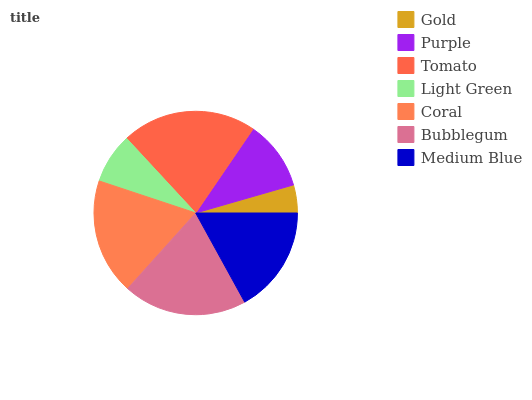Is Gold the minimum?
Answer yes or no. Yes. Is Tomato the maximum?
Answer yes or no. Yes. Is Purple the minimum?
Answer yes or no. No. Is Purple the maximum?
Answer yes or no. No. Is Purple greater than Gold?
Answer yes or no. Yes. Is Gold less than Purple?
Answer yes or no. Yes. Is Gold greater than Purple?
Answer yes or no. No. Is Purple less than Gold?
Answer yes or no. No. Is Medium Blue the high median?
Answer yes or no. Yes. Is Medium Blue the low median?
Answer yes or no. Yes. Is Bubblegum the high median?
Answer yes or no. No. Is Purple the low median?
Answer yes or no. No. 